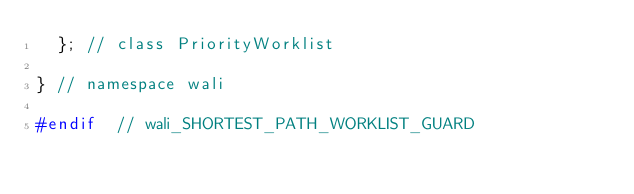<code> <loc_0><loc_0><loc_500><loc_500><_C++_>  }; // class PriorityWorklist

} // namespace wali

#endif  // wali_SHORTEST_PATH_WORKLIST_GUARD

</code> 